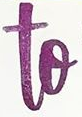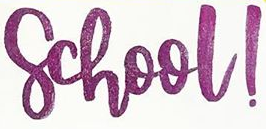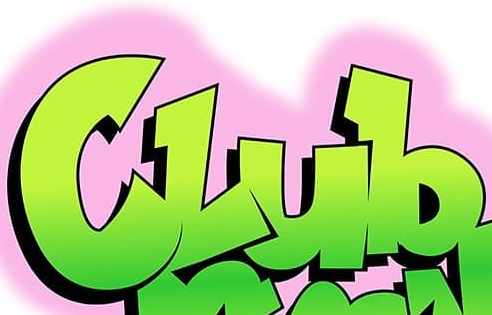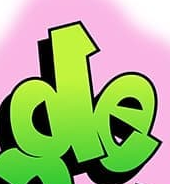What words can you see in these images in sequence, separated by a semicolon? to; school!; Club; de 